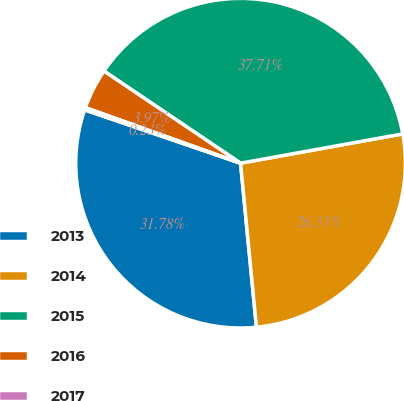<chart> <loc_0><loc_0><loc_500><loc_500><pie_chart><fcel>2013<fcel>2014<fcel>2015<fcel>2016<fcel>2017<nl><fcel>31.78%<fcel>26.31%<fcel>37.71%<fcel>3.97%<fcel>0.23%<nl></chart> 